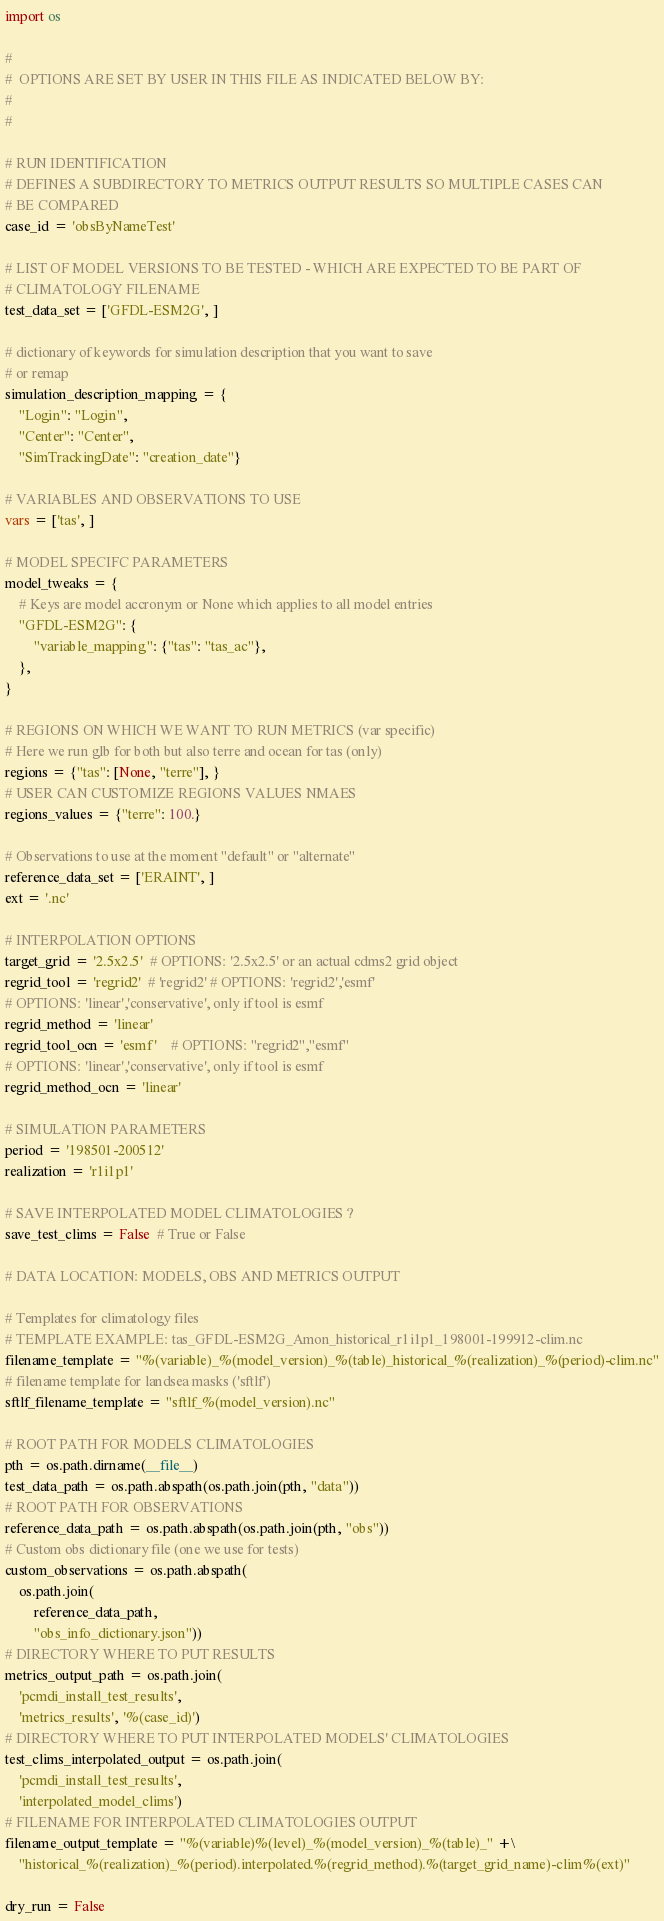Convert code to text. <code><loc_0><loc_0><loc_500><loc_500><_Python_>import os

#
#  OPTIONS ARE SET BY USER IN THIS FILE AS INDICATED BELOW BY:
#
#

# RUN IDENTIFICATION
# DEFINES A SUBDIRECTORY TO METRICS OUTPUT RESULTS SO MULTIPLE CASES CAN
# BE COMPARED
case_id = 'obsByNameTest'

# LIST OF MODEL VERSIONS TO BE TESTED - WHICH ARE EXPECTED TO BE PART OF
# CLIMATOLOGY FILENAME
test_data_set = ['GFDL-ESM2G', ]

# dictionary of keywords for simulation description that you want to save
# or remap
simulation_description_mapping = {
    "Login": "Login",
    "Center": "Center",
    "SimTrackingDate": "creation_date"}

# VARIABLES AND OBSERVATIONS TO USE
vars = ['tas', ]

# MODEL SPECIFC PARAMETERS
model_tweaks = {
    # Keys are model accronym or None which applies to all model entries
    "GFDL-ESM2G": {
        "variable_mapping": {"tas": "tas_ac"},
    },
}

# REGIONS ON WHICH WE WANT TO RUN METRICS (var specific)
# Here we run glb for both but also terre and ocean for tas (only)
regions = {"tas": [None, "terre"], }
# USER CAN CUSTOMIZE REGIONS VALUES NMAES
regions_values = {"terre": 100.}

# Observations to use at the moment "default" or "alternate"
reference_data_set = ['ERAINT', ]
ext = '.nc'

# INTERPOLATION OPTIONS
target_grid = '2.5x2.5'  # OPTIONS: '2.5x2.5' or an actual cdms2 grid object
regrid_tool = 'regrid2'  # 'regrid2' # OPTIONS: 'regrid2','esmf'
# OPTIONS: 'linear','conservative', only if tool is esmf
regrid_method = 'linear'
regrid_tool_ocn = 'esmf'    # OPTIONS: "regrid2","esmf"
# OPTIONS: 'linear','conservative', only if tool is esmf
regrid_method_ocn = 'linear'

# SIMULATION PARAMETERS
period = '198501-200512'
realization = 'r1i1p1'

# SAVE INTERPOLATED MODEL CLIMATOLOGIES ?
save_test_clims = False  # True or False

# DATA LOCATION: MODELS, OBS AND METRICS OUTPUT

# Templates for climatology files
# TEMPLATE EXAMPLE: tas_GFDL-ESM2G_Amon_historical_r1i1p1_198001-199912-clim.nc
filename_template = "%(variable)_%(model_version)_%(table)_historical_%(realization)_%(period)-clim.nc"
# filename template for landsea masks ('sftlf')
sftlf_filename_template = "sftlf_%(model_version).nc"

# ROOT PATH FOR MODELS CLIMATOLOGIES
pth = os.path.dirname(__file__)
test_data_path = os.path.abspath(os.path.join(pth, "data"))
# ROOT PATH FOR OBSERVATIONS
reference_data_path = os.path.abspath(os.path.join(pth, "obs"))
# Custom obs dictionary file (one we use for tests)
custom_observations = os.path.abspath(
    os.path.join(
        reference_data_path,
        "obs_info_dictionary.json"))
# DIRECTORY WHERE TO PUT RESULTS
metrics_output_path = os.path.join(
    'pcmdi_install_test_results',
    'metrics_results', '%(case_id)')
# DIRECTORY WHERE TO PUT INTERPOLATED MODELS' CLIMATOLOGIES
test_clims_interpolated_output = os.path.join(
    'pcmdi_install_test_results',
    'interpolated_model_clims')
# FILENAME FOR INTERPOLATED CLIMATOLOGIES OUTPUT
filename_output_template = "%(variable)%(level)_%(model_version)_%(table)_" +\
    "historical_%(realization)_%(period).interpolated.%(regrid_method).%(target_grid_name)-clim%(ext)"

dry_run = False
</code> 